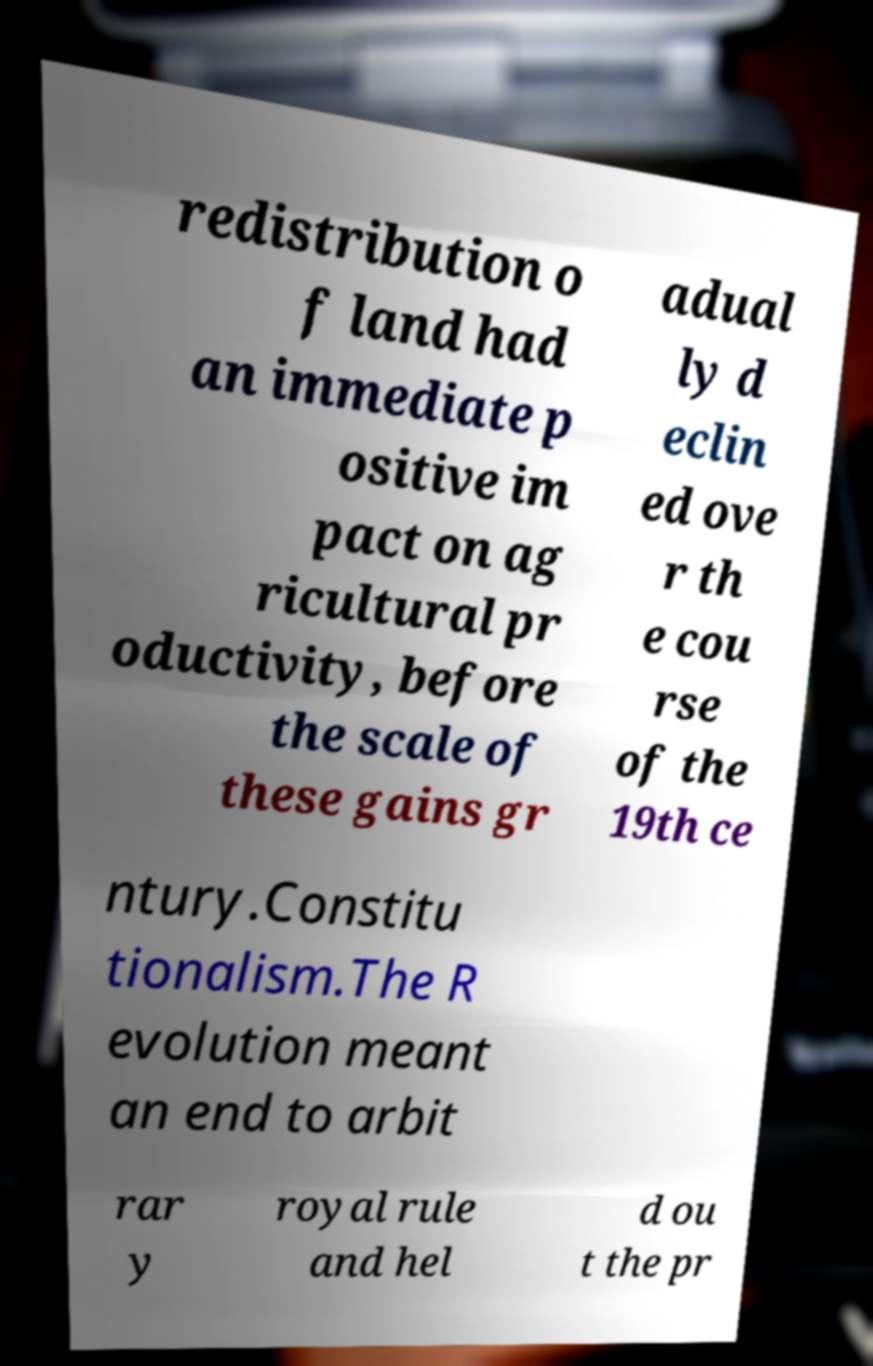For documentation purposes, I need the text within this image transcribed. Could you provide that? redistribution o f land had an immediate p ositive im pact on ag ricultural pr oductivity, before the scale of these gains gr adual ly d eclin ed ove r th e cou rse of the 19th ce ntury.Constitu tionalism.The R evolution meant an end to arbit rar y royal rule and hel d ou t the pr 